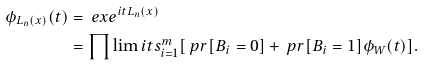<formula> <loc_0><loc_0><loc_500><loc_500>\phi _ { L _ { n } ( x ) } ( t ) & = \ e x e ^ { i t L _ { n } ( x ) } \\ & = \prod \lim i t s _ { i = 1 } ^ { m } [ \ p r [ B _ { i } = 0 ] + \ p r [ B _ { i } = 1 ] \phi _ { W } ( t ) ] .</formula> 